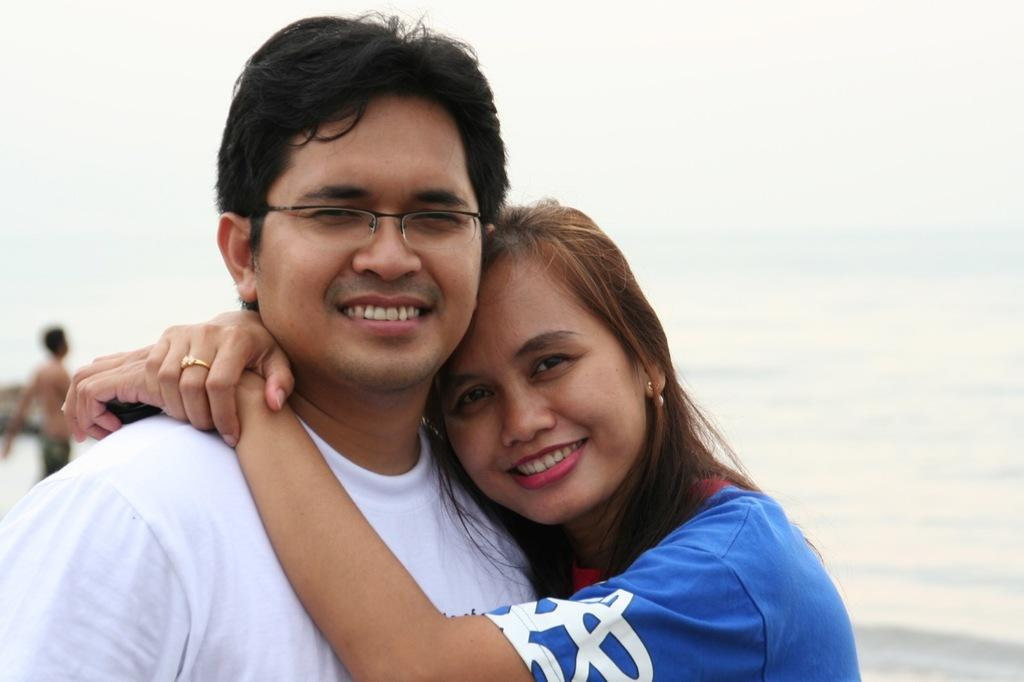How many people are present in the image? There are two people, a man and a woman, present in the image. What is the man wearing in the image? The man is wearing a white shirt in the image. What is the woman wearing in the image? The woman is wearing a blue and white top in the image. What can be seen in the background of the image? There is water visible in the image. What is the color of the sky in the image? The sky is white in color in the image. What type of sound can be heard coming from the mice in the image? There are no mice present in the image, so it is not possible to determine what, if any, sounds they might make. 